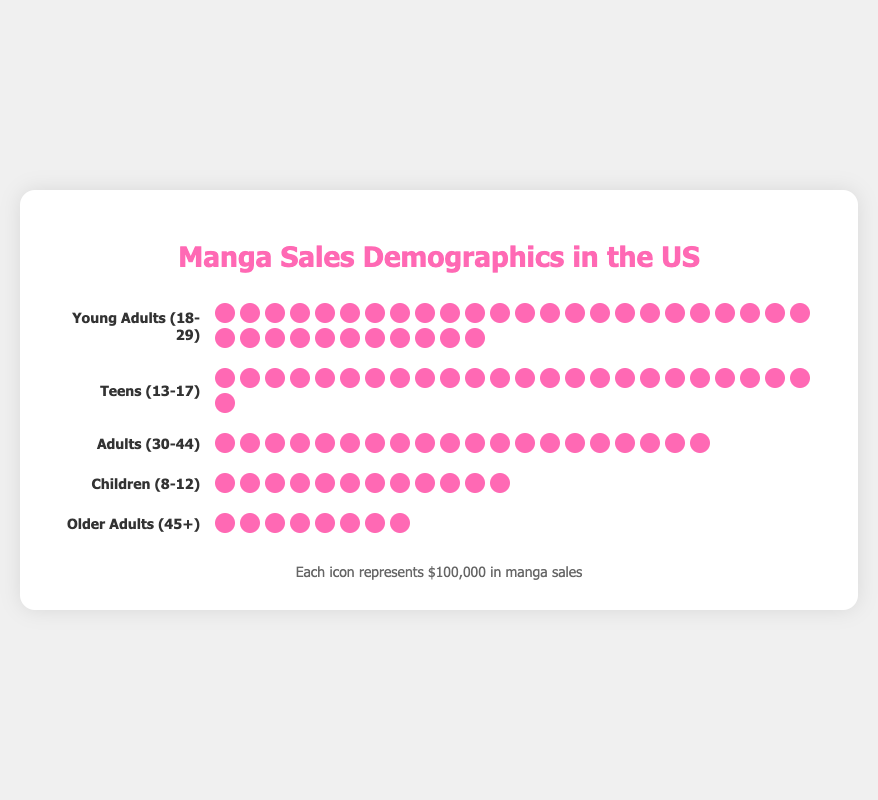What is the title of the plot? The title of the plot is prominently displayed at the top.
Answer: Manga Sales Demographics in the US How many units are represented for Young Adults (18-29)? Each icon represents $100,000. By counting the icons for Young Adults, we see there are 35 icons.
Answer: 35 units Which demographic group has the least manga sales? By comparing the number of icons for each demographic, we see that Older Adults (45+) have the least number of icons.
Answer: Older Adults (45+) How much total revenue is represented by the Teens (13-17) demographic? Each icon represents $100,000, and there are 25 icons for Teens. 25 times $100,000 equals $2,500,000.
Answer: $2,500,000 What is the combined sales revenue of the Adults (30-44) and Children (8-12) demographics? Adults have 20 icons ($2,000,000) and Children have 12 icons ($1,200,000). Summing these gives $2,000,000 + $1,200,000 = $3,200,000.
Answer: $3,200,000 How many more units are represented by Young Adults (18-29) compared to Older Adults (45+)? Young Adults have 35 icons, and Older Adults have 8 icons. The difference is 35 - 8 = 27 units.
Answer: 27 units Which demographic has more units of manga sales, Teens or Adults (30-44)? Comparing the icons, Teens have 25 units and Adults have 20 units. Teens have more units.
Answer: Teens (13-17) How much more revenue do Young Adults (18-29) generate than Children (8-12)? Young Adults have 35 icons ($3,500,000) and Children have 12 icons ($1,200,000). The difference is $3,500,000 - $1,200,000 = $2,300,000.
Answer: $2,300,000 What is the total number of units represented in the plot? Summing the icons for each group: 35 (Young Adults) + 25 (Teens) + 20 (Adults) + 12 (Children) + 8 (Older Adults) = 100 units.
Answer: 100 units If each icon represents $100,000, what is the total sales revenue represented in the plot? The total number of icons is 100, and each represents $100,000. So, 100 * 100,000 = $10,000,000.
Answer: $10,000,000 